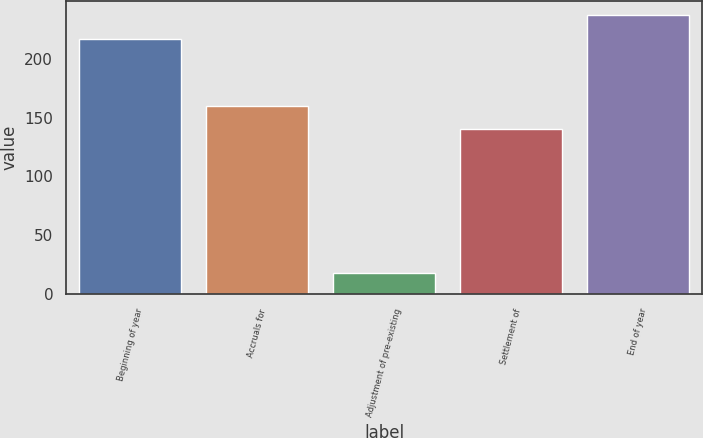<chart> <loc_0><loc_0><loc_500><loc_500><bar_chart><fcel>Beginning of year<fcel>Accruals for<fcel>Adjustment of pre-existing<fcel>Settlement of<fcel>End of year<nl><fcel>217<fcel>159.9<fcel>18<fcel>140<fcel>236.9<nl></chart> 